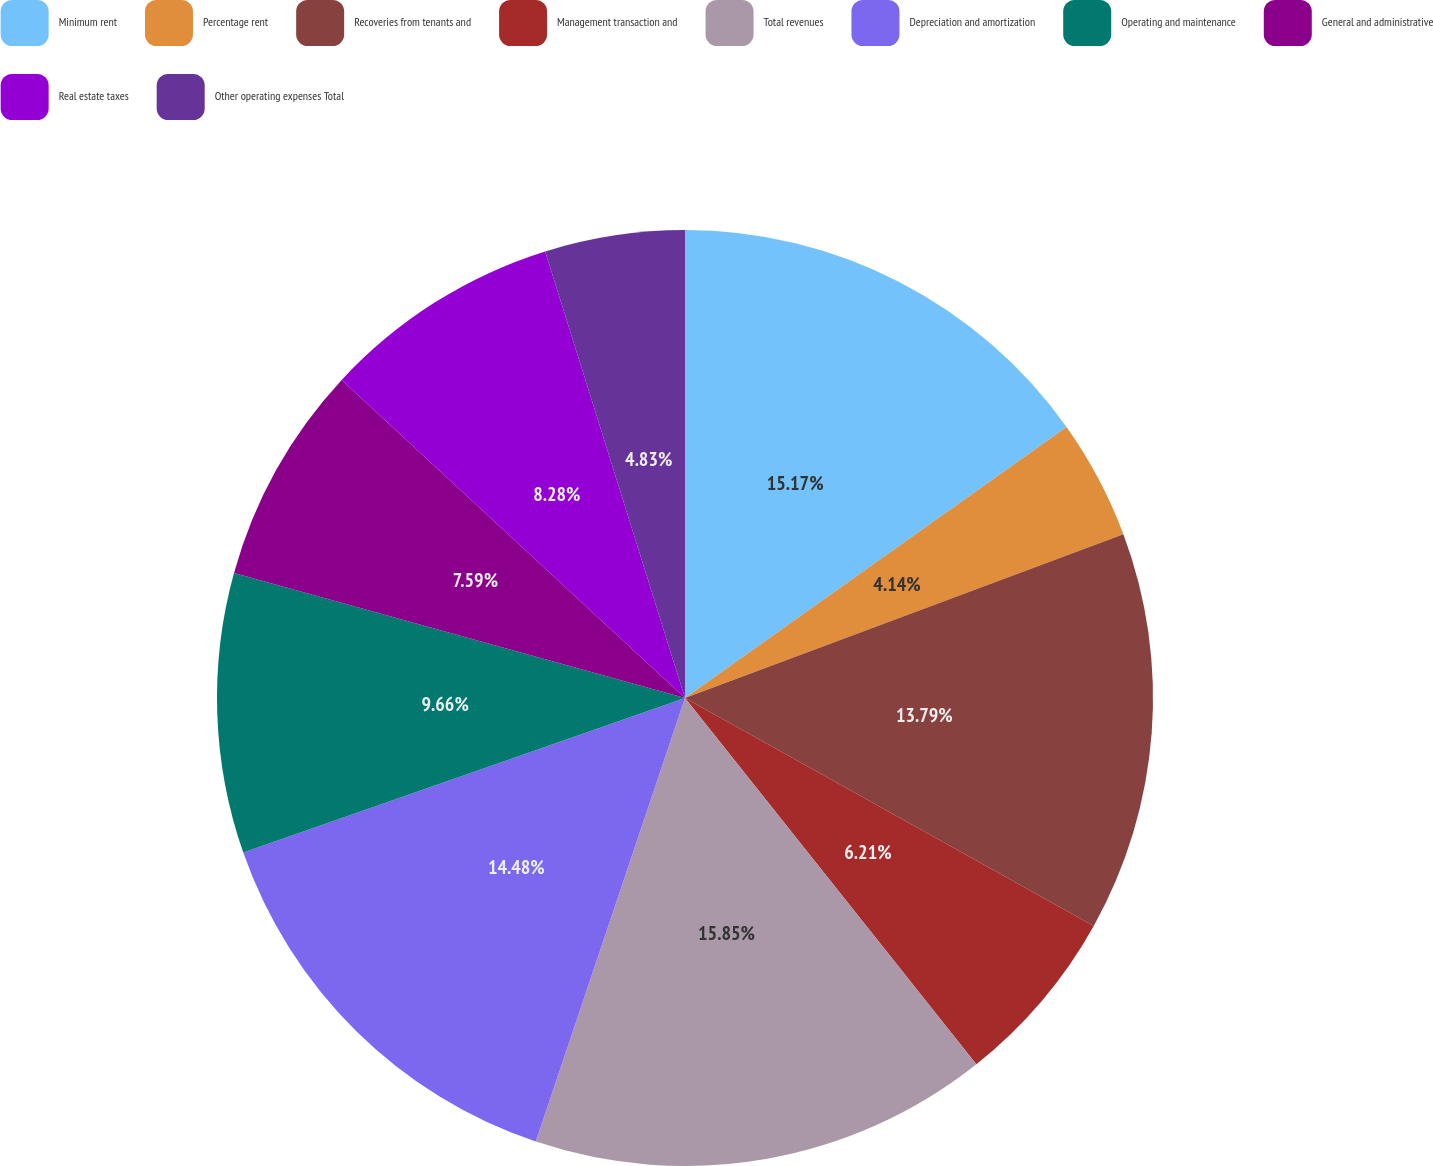Convert chart to OTSL. <chart><loc_0><loc_0><loc_500><loc_500><pie_chart><fcel>Minimum rent<fcel>Percentage rent<fcel>Recoveries from tenants and<fcel>Management transaction and<fcel>Total revenues<fcel>Depreciation and amortization<fcel>Operating and maintenance<fcel>General and administrative<fcel>Real estate taxes<fcel>Other operating expenses Total<nl><fcel>15.17%<fcel>4.14%<fcel>13.79%<fcel>6.21%<fcel>15.86%<fcel>14.48%<fcel>9.66%<fcel>7.59%<fcel>8.28%<fcel>4.83%<nl></chart> 